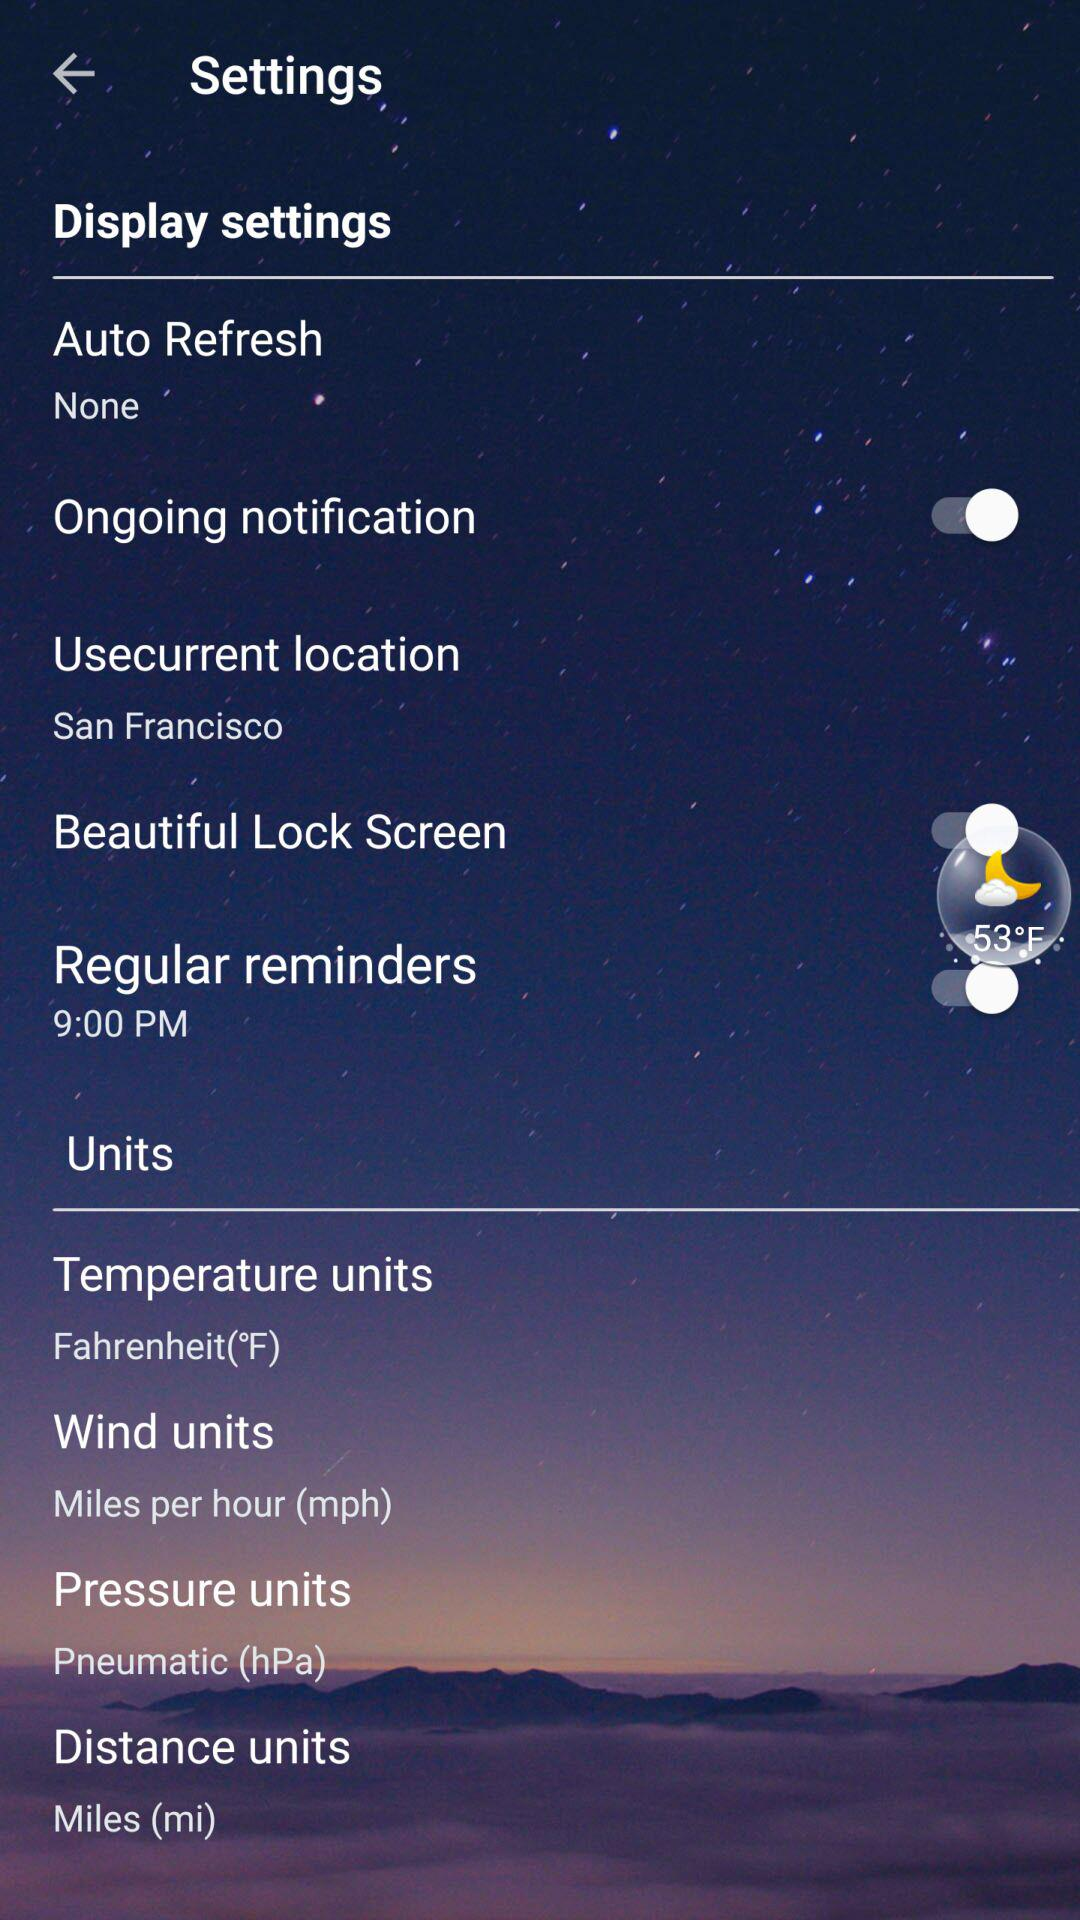What is the "Usecurrent location"? The "Usecurrent location" is San Francisco. 